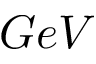Convert formula to latex. <formula><loc_0><loc_0><loc_500><loc_500>G e V</formula> 